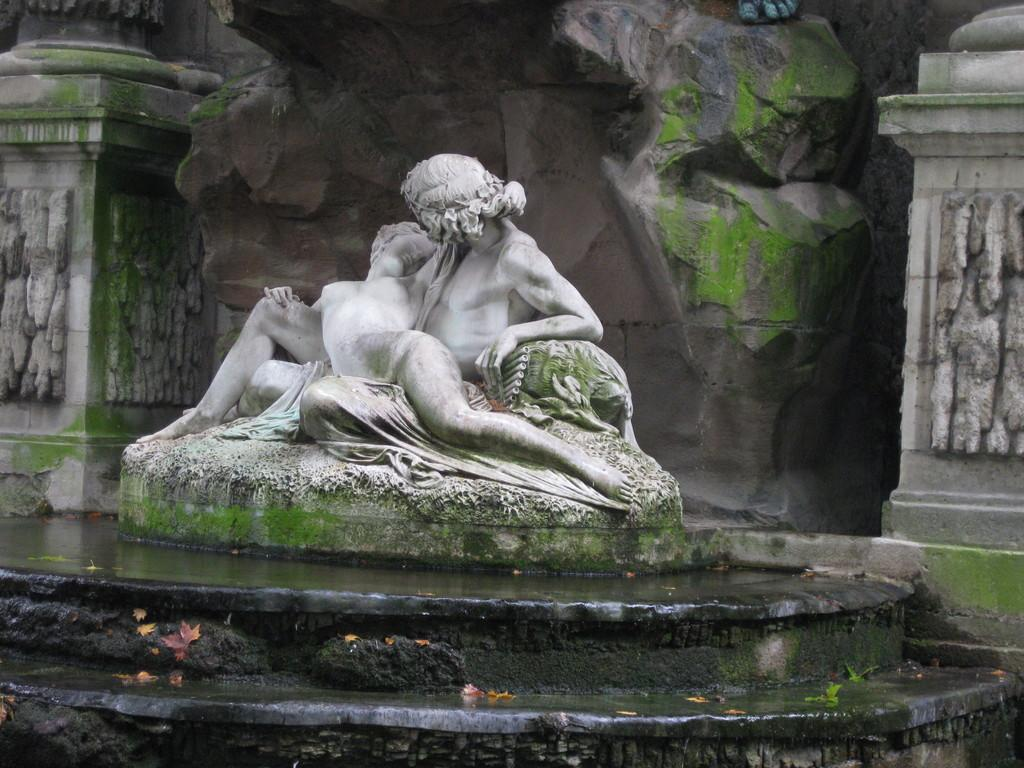What is the main subject of the image? There is a sculpture in the image. What does the sculpture resemble? The sculpture resembles humans. What can be seen in the background of the image? There are stone structures in the background of the image. How do the stone structures appear? The stone structures look like pillars. What song is the stranger singing in the image? There is no stranger or song present in the image; it features a sculpture and stone structures. 